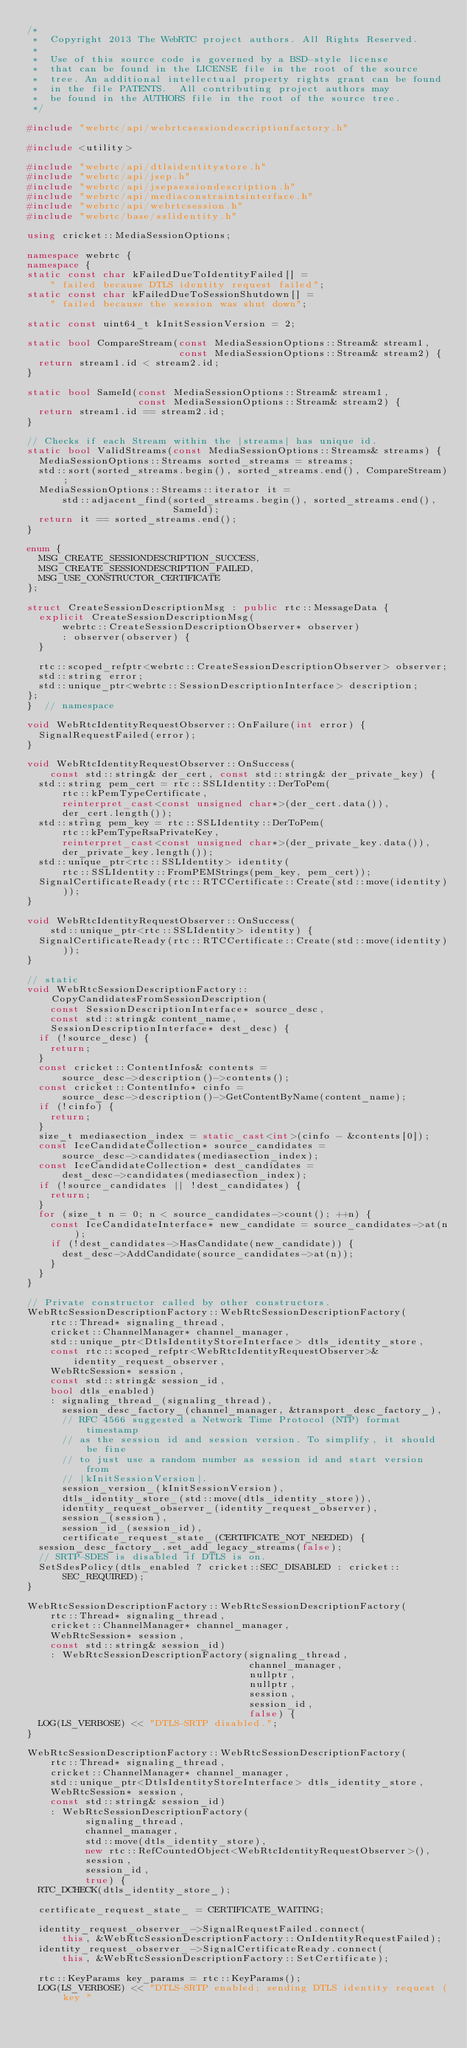<code> <loc_0><loc_0><loc_500><loc_500><_C++_>/*
 *  Copyright 2013 The WebRTC project authors. All Rights Reserved.
 *
 *  Use of this source code is governed by a BSD-style license
 *  that can be found in the LICENSE file in the root of the source
 *  tree. An additional intellectual property rights grant can be found
 *  in the file PATENTS.  All contributing project authors may
 *  be found in the AUTHORS file in the root of the source tree.
 */

#include "webrtc/api/webrtcsessiondescriptionfactory.h"

#include <utility>

#include "webrtc/api/dtlsidentitystore.h"
#include "webrtc/api/jsep.h"
#include "webrtc/api/jsepsessiondescription.h"
#include "webrtc/api/mediaconstraintsinterface.h"
#include "webrtc/api/webrtcsession.h"
#include "webrtc/base/sslidentity.h"

using cricket::MediaSessionOptions;

namespace webrtc {
namespace {
static const char kFailedDueToIdentityFailed[] =
    " failed because DTLS identity request failed";
static const char kFailedDueToSessionShutdown[] =
    " failed because the session was shut down";

static const uint64_t kInitSessionVersion = 2;

static bool CompareStream(const MediaSessionOptions::Stream& stream1,
                          const MediaSessionOptions::Stream& stream2) {
  return stream1.id < stream2.id;
}

static bool SameId(const MediaSessionOptions::Stream& stream1,
                   const MediaSessionOptions::Stream& stream2) {
  return stream1.id == stream2.id;
}

// Checks if each Stream within the |streams| has unique id.
static bool ValidStreams(const MediaSessionOptions::Streams& streams) {
  MediaSessionOptions::Streams sorted_streams = streams;
  std::sort(sorted_streams.begin(), sorted_streams.end(), CompareStream);
  MediaSessionOptions::Streams::iterator it =
      std::adjacent_find(sorted_streams.begin(), sorted_streams.end(),
                         SameId);
  return it == sorted_streams.end();
}

enum {
  MSG_CREATE_SESSIONDESCRIPTION_SUCCESS,
  MSG_CREATE_SESSIONDESCRIPTION_FAILED,
  MSG_USE_CONSTRUCTOR_CERTIFICATE
};

struct CreateSessionDescriptionMsg : public rtc::MessageData {
  explicit CreateSessionDescriptionMsg(
      webrtc::CreateSessionDescriptionObserver* observer)
      : observer(observer) {
  }

  rtc::scoped_refptr<webrtc::CreateSessionDescriptionObserver> observer;
  std::string error;
  std::unique_ptr<webrtc::SessionDescriptionInterface> description;
};
}  // namespace

void WebRtcIdentityRequestObserver::OnFailure(int error) {
  SignalRequestFailed(error);
}

void WebRtcIdentityRequestObserver::OnSuccess(
    const std::string& der_cert, const std::string& der_private_key) {
  std::string pem_cert = rtc::SSLIdentity::DerToPem(
      rtc::kPemTypeCertificate,
      reinterpret_cast<const unsigned char*>(der_cert.data()),
      der_cert.length());
  std::string pem_key = rtc::SSLIdentity::DerToPem(
      rtc::kPemTypeRsaPrivateKey,
      reinterpret_cast<const unsigned char*>(der_private_key.data()),
      der_private_key.length());
  std::unique_ptr<rtc::SSLIdentity> identity(
      rtc::SSLIdentity::FromPEMStrings(pem_key, pem_cert));
  SignalCertificateReady(rtc::RTCCertificate::Create(std::move(identity)));
}

void WebRtcIdentityRequestObserver::OnSuccess(
    std::unique_ptr<rtc::SSLIdentity> identity) {
  SignalCertificateReady(rtc::RTCCertificate::Create(std::move(identity)));
}

// static
void WebRtcSessionDescriptionFactory::CopyCandidatesFromSessionDescription(
    const SessionDescriptionInterface* source_desc,
    const std::string& content_name,
    SessionDescriptionInterface* dest_desc) {
  if (!source_desc) {
    return;
  }
  const cricket::ContentInfos& contents =
      source_desc->description()->contents();
  const cricket::ContentInfo* cinfo =
      source_desc->description()->GetContentByName(content_name);
  if (!cinfo) {
    return;
  }
  size_t mediasection_index = static_cast<int>(cinfo - &contents[0]);
  const IceCandidateCollection* source_candidates =
      source_desc->candidates(mediasection_index);
  const IceCandidateCollection* dest_candidates =
      dest_desc->candidates(mediasection_index);
  if (!source_candidates || !dest_candidates) {
    return;
  }
  for (size_t n = 0; n < source_candidates->count(); ++n) {
    const IceCandidateInterface* new_candidate = source_candidates->at(n);
    if (!dest_candidates->HasCandidate(new_candidate)) {
      dest_desc->AddCandidate(source_candidates->at(n));
    }
  }
}

// Private constructor called by other constructors.
WebRtcSessionDescriptionFactory::WebRtcSessionDescriptionFactory(
    rtc::Thread* signaling_thread,
    cricket::ChannelManager* channel_manager,
    std::unique_ptr<DtlsIdentityStoreInterface> dtls_identity_store,
    const rtc::scoped_refptr<WebRtcIdentityRequestObserver>&
        identity_request_observer,
    WebRtcSession* session,
    const std::string& session_id,
    bool dtls_enabled)
    : signaling_thread_(signaling_thread),
      session_desc_factory_(channel_manager, &transport_desc_factory_),
      // RFC 4566 suggested a Network Time Protocol (NTP) format timestamp
      // as the session id and session version. To simplify, it should be fine
      // to just use a random number as session id and start version from
      // |kInitSessionVersion|.
      session_version_(kInitSessionVersion),
      dtls_identity_store_(std::move(dtls_identity_store)),
      identity_request_observer_(identity_request_observer),
      session_(session),
      session_id_(session_id),
      certificate_request_state_(CERTIFICATE_NOT_NEEDED) {
  session_desc_factory_.set_add_legacy_streams(false);
  // SRTP-SDES is disabled if DTLS is on.
  SetSdesPolicy(dtls_enabled ? cricket::SEC_DISABLED : cricket::SEC_REQUIRED);
}

WebRtcSessionDescriptionFactory::WebRtcSessionDescriptionFactory(
    rtc::Thread* signaling_thread,
    cricket::ChannelManager* channel_manager,
    WebRtcSession* session,
    const std::string& session_id)
    : WebRtcSessionDescriptionFactory(signaling_thread,
                                      channel_manager,
                                      nullptr,
                                      nullptr,
                                      session,
                                      session_id,
                                      false) {
  LOG(LS_VERBOSE) << "DTLS-SRTP disabled.";
}

WebRtcSessionDescriptionFactory::WebRtcSessionDescriptionFactory(
    rtc::Thread* signaling_thread,
    cricket::ChannelManager* channel_manager,
    std::unique_ptr<DtlsIdentityStoreInterface> dtls_identity_store,
    WebRtcSession* session,
    const std::string& session_id)
    : WebRtcSessionDescriptionFactory(
          signaling_thread,
          channel_manager,
          std::move(dtls_identity_store),
          new rtc::RefCountedObject<WebRtcIdentityRequestObserver>(),
          session,
          session_id,
          true) {
  RTC_DCHECK(dtls_identity_store_);

  certificate_request_state_ = CERTIFICATE_WAITING;

  identity_request_observer_->SignalRequestFailed.connect(
      this, &WebRtcSessionDescriptionFactory::OnIdentityRequestFailed);
  identity_request_observer_->SignalCertificateReady.connect(
      this, &WebRtcSessionDescriptionFactory::SetCertificate);

  rtc::KeyParams key_params = rtc::KeyParams();
  LOG(LS_VERBOSE) << "DTLS-SRTP enabled; sending DTLS identity request (key "</code> 